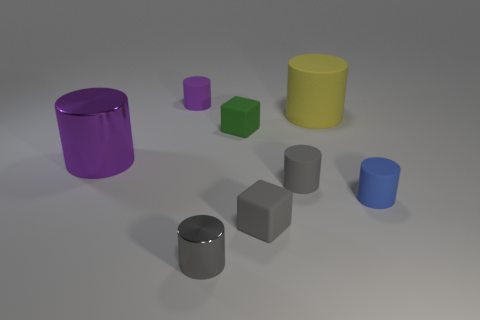There is a blue thing that is the same size as the green cube; what is its shape?
Provide a short and direct response. Cylinder. How many other things are the same color as the big metallic thing?
Provide a short and direct response. 1. What number of other things are the same material as the small green cube?
Provide a succinct answer. 5. There is a green matte object; is its size the same as the matte cylinder behind the big matte cylinder?
Make the answer very short. Yes. What color is the large rubber cylinder?
Offer a terse response. Yellow. There is a purple thing right of the cylinder that is on the left side of the purple cylinder that is behind the green matte cube; what shape is it?
Offer a very short reply. Cylinder. The large thing that is behind the large metallic thing that is left of the small purple rubber thing is made of what material?
Your answer should be compact. Rubber. There is a object that is the same material as the big purple cylinder; what shape is it?
Offer a very short reply. Cylinder. Is there anything else that is the same shape as the tiny shiny thing?
Keep it short and to the point. Yes. What number of small blue cylinders are in front of the large metal thing?
Offer a terse response. 1. 